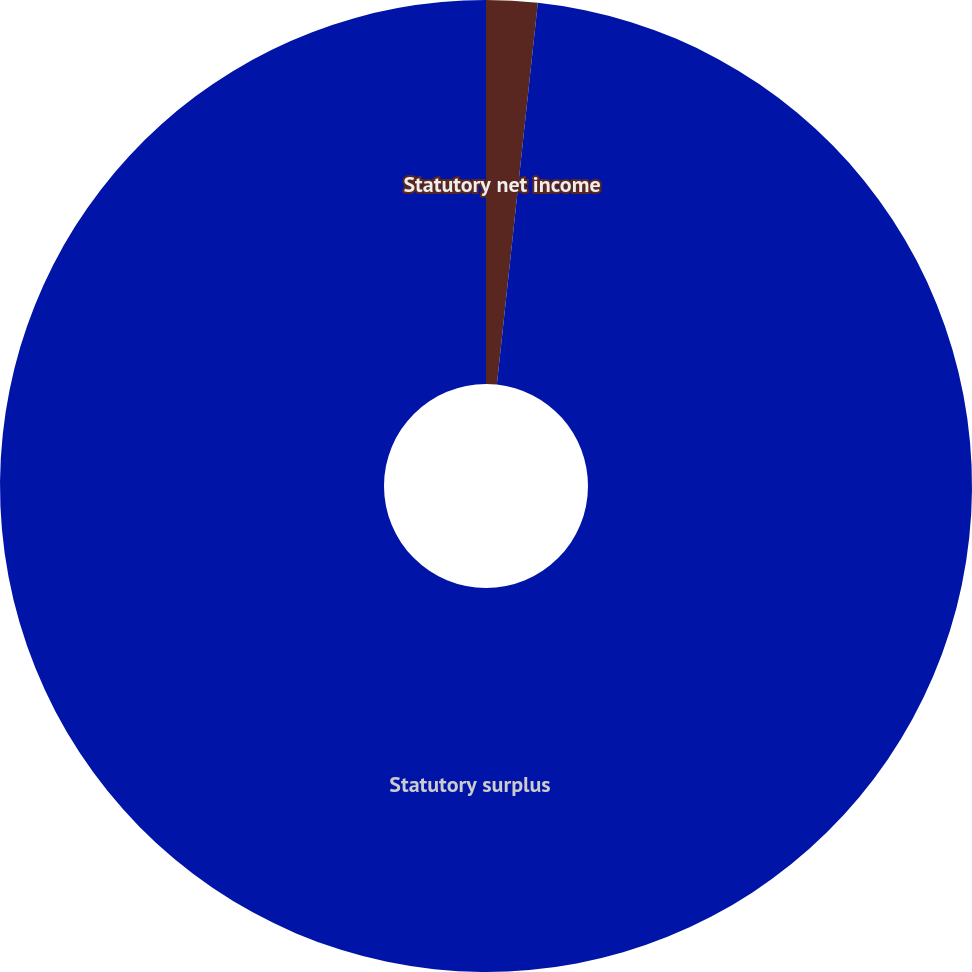Convert chart. <chart><loc_0><loc_0><loc_500><loc_500><pie_chart><fcel>Statutory net income<fcel>Statutory surplus<nl><fcel>1.7%<fcel>98.3%<nl></chart> 